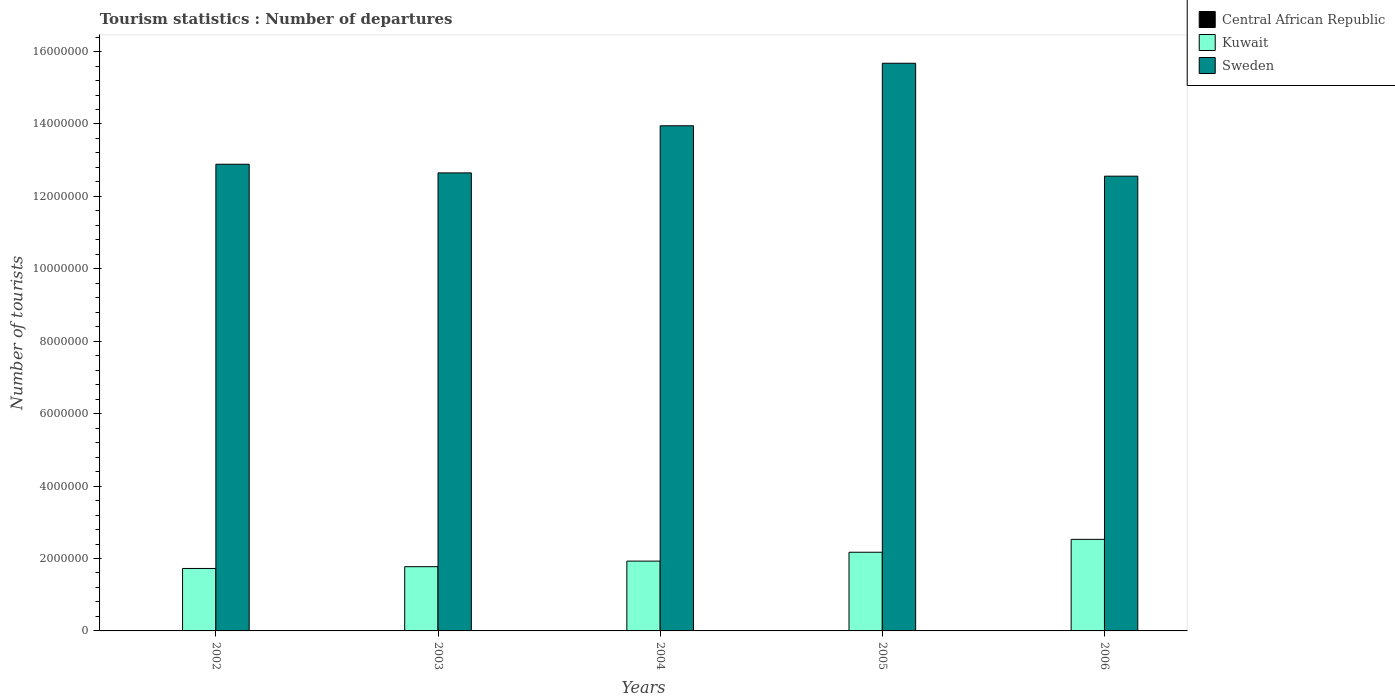Are the number of bars per tick equal to the number of legend labels?
Your answer should be very brief. Yes. Are the number of bars on each tick of the X-axis equal?
Your answer should be very brief. Yes. How many bars are there on the 4th tick from the right?
Keep it short and to the point. 3. What is the label of the 2nd group of bars from the left?
Keep it short and to the point. 2003. In how many cases, is the number of bars for a given year not equal to the number of legend labels?
Your answer should be very brief. 0. What is the number of tourist departures in Sweden in 2003?
Give a very brief answer. 1.26e+07. Across all years, what is the maximum number of tourist departures in Kuwait?
Provide a succinct answer. 2.53e+06. Across all years, what is the minimum number of tourist departures in Sweden?
Provide a succinct answer. 1.26e+07. In which year was the number of tourist departures in Central African Republic maximum?
Offer a terse response. 2006. In which year was the number of tourist departures in Kuwait minimum?
Provide a short and direct response. 2002. What is the total number of tourist departures in Sweden in the graph?
Your answer should be compact. 6.77e+07. What is the difference between the number of tourist departures in Sweden in 2002 and that in 2006?
Provide a short and direct response. 3.29e+05. What is the difference between the number of tourist departures in Kuwait in 2003 and the number of tourist departures in Sweden in 2002?
Make the answer very short. -1.11e+07. What is the average number of tourist departures in Central African Republic per year?
Provide a short and direct response. 7400. In the year 2003, what is the difference between the number of tourist departures in Central African Republic and number of tourist departures in Sweden?
Offer a very short reply. -1.26e+07. What is the ratio of the number of tourist departures in Kuwait in 2002 to that in 2005?
Your answer should be compact. 0.79. Is the difference between the number of tourist departures in Central African Republic in 2003 and 2006 greater than the difference between the number of tourist departures in Sweden in 2003 and 2006?
Offer a terse response. No. What is the difference between the highest and the second highest number of tourist departures in Kuwait?
Keep it short and to the point. 3.56e+05. What is the difference between the highest and the lowest number of tourist departures in Kuwait?
Give a very brief answer. 8.04e+05. In how many years, is the number of tourist departures in Central African Republic greater than the average number of tourist departures in Central African Republic taken over all years?
Your answer should be very brief. 2. What does the 1st bar from the left in 2006 represents?
Your answer should be compact. Central African Republic. What does the 2nd bar from the right in 2004 represents?
Offer a terse response. Kuwait. How many years are there in the graph?
Your answer should be compact. 5. What is the difference between two consecutive major ticks on the Y-axis?
Your answer should be very brief. 2.00e+06. Are the values on the major ticks of Y-axis written in scientific E-notation?
Offer a very short reply. No. Does the graph contain any zero values?
Give a very brief answer. No. How many legend labels are there?
Your answer should be compact. 3. How are the legend labels stacked?
Make the answer very short. Vertical. What is the title of the graph?
Your answer should be very brief. Tourism statistics : Number of departures. What is the label or title of the Y-axis?
Give a very brief answer. Number of tourists. What is the Number of tourists of Kuwait in 2002?
Ensure brevity in your answer.  1.72e+06. What is the Number of tourists of Sweden in 2002?
Provide a succinct answer. 1.29e+07. What is the Number of tourists of Central African Republic in 2003?
Offer a very short reply. 6000. What is the Number of tourists in Kuwait in 2003?
Your answer should be compact. 1.77e+06. What is the Number of tourists in Sweden in 2003?
Your response must be concise. 1.26e+07. What is the Number of tourists in Central African Republic in 2004?
Keep it short and to the point. 7000. What is the Number of tourists of Kuwait in 2004?
Ensure brevity in your answer.  1.93e+06. What is the Number of tourists of Sweden in 2004?
Ensure brevity in your answer.  1.40e+07. What is the Number of tourists of Central African Republic in 2005?
Give a very brief answer. 8000. What is the Number of tourists of Kuwait in 2005?
Give a very brief answer. 2.17e+06. What is the Number of tourists of Sweden in 2005?
Give a very brief answer. 1.57e+07. What is the Number of tourists in Central African Republic in 2006?
Provide a succinct answer. 1.10e+04. What is the Number of tourists in Kuwait in 2006?
Provide a succinct answer. 2.53e+06. What is the Number of tourists in Sweden in 2006?
Your answer should be compact. 1.26e+07. Across all years, what is the maximum Number of tourists of Central African Republic?
Give a very brief answer. 1.10e+04. Across all years, what is the maximum Number of tourists of Kuwait?
Ensure brevity in your answer.  2.53e+06. Across all years, what is the maximum Number of tourists of Sweden?
Offer a terse response. 1.57e+07. Across all years, what is the minimum Number of tourists in Kuwait?
Give a very brief answer. 1.72e+06. Across all years, what is the minimum Number of tourists of Sweden?
Give a very brief answer. 1.26e+07. What is the total Number of tourists in Central African Republic in the graph?
Offer a very short reply. 3.70e+04. What is the total Number of tourists in Kuwait in the graph?
Provide a succinct answer. 1.01e+07. What is the total Number of tourists in Sweden in the graph?
Your answer should be very brief. 6.77e+07. What is the difference between the Number of tourists in Central African Republic in 2002 and that in 2003?
Keep it short and to the point. -1000. What is the difference between the Number of tourists in Kuwait in 2002 and that in 2003?
Give a very brief answer. -4.90e+04. What is the difference between the Number of tourists in Sweden in 2002 and that in 2003?
Offer a terse response. 2.39e+05. What is the difference between the Number of tourists in Central African Republic in 2002 and that in 2004?
Offer a very short reply. -2000. What is the difference between the Number of tourists of Kuwait in 2002 and that in 2004?
Make the answer very short. -2.03e+05. What is the difference between the Number of tourists in Sweden in 2002 and that in 2004?
Ensure brevity in your answer.  -1.06e+06. What is the difference between the Number of tourists of Central African Republic in 2002 and that in 2005?
Offer a very short reply. -3000. What is the difference between the Number of tourists of Kuwait in 2002 and that in 2005?
Make the answer very short. -4.48e+05. What is the difference between the Number of tourists in Sweden in 2002 and that in 2005?
Provide a short and direct response. -2.79e+06. What is the difference between the Number of tourists of Central African Republic in 2002 and that in 2006?
Keep it short and to the point. -6000. What is the difference between the Number of tourists in Kuwait in 2002 and that in 2006?
Ensure brevity in your answer.  -8.04e+05. What is the difference between the Number of tourists of Sweden in 2002 and that in 2006?
Keep it short and to the point. 3.29e+05. What is the difference between the Number of tourists in Central African Republic in 2003 and that in 2004?
Keep it short and to the point. -1000. What is the difference between the Number of tourists in Kuwait in 2003 and that in 2004?
Ensure brevity in your answer.  -1.54e+05. What is the difference between the Number of tourists of Sweden in 2003 and that in 2004?
Offer a very short reply. -1.30e+06. What is the difference between the Number of tourists in Central African Republic in 2003 and that in 2005?
Offer a terse response. -2000. What is the difference between the Number of tourists of Kuwait in 2003 and that in 2005?
Make the answer very short. -3.99e+05. What is the difference between the Number of tourists of Sweden in 2003 and that in 2005?
Offer a terse response. -3.03e+06. What is the difference between the Number of tourists of Central African Republic in 2003 and that in 2006?
Give a very brief answer. -5000. What is the difference between the Number of tourists of Kuwait in 2003 and that in 2006?
Your answer should be very brief. -7.55e+05. What is the difference between the Number of tourists of Central African Republic in 2004 and that in 2005?
Offer a terse response. -1000. What is the difference between the Number of tourists in Kuwait in 2004 and that in 2005?
Your response must be concise. -2.45e+05. What is the difference between the Number of tourists in Sweden in 2004 and that in 2005?
Your response must be concise. -1.73e+06. What is the difference between the Number of tourists of Central African Republic in 2004 and that in 2006?
Give a very brief answer. -4000. What is the difference between the Number of tourists in Kuwait in 2004 and that in 2006?
Your response must be concise. -6.01e+05. What is the difference between the Number of tourists of Sweden in 2004 and that in 2006?
Your answer should be compact. 1.39e+06. What is the difference between the Number of tourists in Central African Republic in 2005 and that in 2006?
Your answer should be compact. -3000. What is the difference between the Number of tourists of Kuwait in 2005 and that in 2006?
Ensure brevity in your answer.  -3.56e+05. What is the difference between the Number of tourists in Sweden in 2005 and that in 2006?
Keep it short and to the point. 3.12e+06. What is the difference between the Number of tourists in Central African Republic in 2002 and the Number of tourists in Kuwait in 2003?
Provide a succinct answer. -1.77e+06. What is the difference between the Number of tourists of Central African Republic in 2002 and the Number of tourists of Sweden in 2003?
Provide a succinct answer. -1.26e+07. What is the difference between the Number of tourists of Kuwait in 2002 and the Number of tourists of Sweden in 2003?
Ensure brevity in your answer.  -1.09e+07. What is the difference between the Number of tourists of Central African Republic in 2002 and the Number of tourists of Kuwait in 2004?
Offer a terse response. -1.92e+06. What is the difference between the Number of tourists of Central African Republic in 2002 and the Number of tourists of Sweden in 2004?
Your answer should be compact. -1.39e+07. What is the difference between the Number of tourists in Kuwait in 2002 and the Number of tourists in Sweden in 2004?
Your answer should be compact. -1.22e+07. What is the difference between the Number of tourists of Central African Republic in 2002 and the Number of tourists of Kuwait in 2005?
Ensure brevity in your answer.  -2.17e+06. What is the difference between the Number of tourists of Central African Republic in 2002 and the Number of tourists of Sweden in 2005?
Keep it short and to the point. -1.57e+07. What is the difference between the Number of tourists in Kuwait in 2002 and the Number of tourists in Sweden in 2005?
Your answer should be very brief. -1.40e+07. What is the difference between the Number of tourists of Central African Republic in 2002 and the Number of tourists of Kuwait in 2006?
Provide a short and direct response. -2.52e+06. What is the difference between the Number of tourists in Central African Republic in 2002 and the Number of tourists in Sweden in 2006?
Ensure brevity in your answer.  -1.26e+07. What is the difference between the Number of tourists in Kuwait in 2002 and the Number of tourists in Sweden in 2006?
Provide a short and direct response. -1.08e+07. What is the difference between the Number of tourists of Central African Republic in 2003 and the Number of tourists of Kuwait in 2004?
Provide a succinct answer. -1.92e+06. What is the difference between the Number of tourists of Central African Republic in 2003 and the Number of tourists of Sweden in 2004?
Your answer should be compact. -1.39e+07. What is the difference between the Number of tourists in Kuwait in 2003 and the Number of tourists in Sweden in 2004?
Give a very brief answer. -1.22e+07. What is the difference between the Number of tourists in Central African Republic in 2003 and the Number of tourists in Kuwait in 2005?
Provide a short and direct response. -2.17e+06. What is the difference between the Number of tourists in Central African Republic in 2003 and the Number of tourists in Sweden in 2005?
Your answer should be very brief. -1.57e+07. What is the difference between the Number of tourists of Kuwait in 2003 and the Number of tourists of Sweden in 2005?
Offer a very short reply. -1.39e+07. What is the difference between the Number of tourists in Central African Republic in 2003 and the Number of tourists in Kuwait in 2006?
Offer a terse response. -2.52e+06. What is the difference between the Number of tourists in Central African Republic in 2003 and the Number of tourists in Sweden in 2006?
Your answer should be compact. -1.26e+07. What is the difference between the Number of tourists in Kuwait in 2003 and the Number of tourists in Sweden in 2006?
Provide a short and direct response. -1.08e+07. What is the difference between the Number of tourists of Central African Republic in 2004 and the Number of tourists of Kuwait in 2005?
Give a very brief answer. -2.17e+06. What is the difference between the Number of tourists of Central African Republic in 2004 and the Number of tourists of Sweden in 2005?
Offer a very short reply. -1.57e+07. What is the difference between the Number of tourists of Kuwait in 2004 and the Number of tourists of Sweden in 2005?
Provide a short and direct response. -1.37e+07. What is the difference between the Number of tourists of Central African Republic in 2004 and the Number of tourists of Kuwait in 2006?
Offer a terse response. -2.52e+06. What is the difference between the Number of tourists of Central African Republic in 2004 and the Number of tourists of Sweden in 2006?
Give a very brief answer. -1.26e+07. What is the difference between the Number of tourists of Kuwait in 2004 and the Number of tourists of Sweden in 2006?
Give a very brief answer. -1.06e+07. What is the difference between the Number of tourists of Central African Republic in 2005 and the Number of tourists of Kuwait in 2006?
Offer a very short reply. -2.52e+06. What is the difference between the Number of tourists of Central African Republic in 2005 and the Number of tourists of Sweden in 2006?
Keep it short and to the point. -1.26e+07. What is the difference between the Number of tourists in Kuwait in 2005 and the Number of tourists in Sweden in 2006?
Offer a very short reply. -1.04e+07. What is the average Number of tourists of Central African Republic per year?
Make the answer very short. 7400. What is the average Number of tourists of Kuwait per year?
Keep it short and to the point. 2.03e+06. What is the average Number of tourists in Sweden per year?
Provide a succinct answer. 1.35e+07. In the year 2002, what is the difference between the Number of tourists in Central African Republic and Number of tourists in Kuwait?
Your answer should be very brief. -1.72e+06. In the year 2002, what is the difference between the Number of tourists in Central African Republic and Number of tourists in Sweden?
Your answer should be compact. -1.29e+07. In the year 2002, what is the difference between the Number of tourists in Kuwait and Number of tourists in Sweden?
Keep it short and to the point. -1.12e+07. In the year 2003, what is the difference between the Number of tourists in Central African Republic and Number of tourists in Kuwait?
Offer a very short reply. -1.77e+06. In the year 2003, what is the difference between the Number of tourists in Central African Republic and Number of tourists in Sweden?
Provide a succinct answer. -1.26e+07. In the year 2003, what is the difference between the Number of tourists in Kuwait and Number of tourists in Sweden?
Provide a short and direct response. -1.09e+07. In the year 2004, what is the difference between the Number of tourists in Central African Republic and Number of tourists in Kuwait?
Give a very brief answer. -1.92e+06. In the year 2004, what is the difference between the Number of tourists in Central African Republic and Number of tourists in Sweden?
Offer a terse response. -1.39e+07. In the year 2004, what is the difference between the Number of tourists of Kuwait and Number of tourists of Sweden?
Give a very brief answer. -1.20e+07. In the year 2005, what is the difference between the Number of tourists of Central African Republic and Number of tourists of Kuwait?
Offer a very short reply. -2.16e+06. In the year 2005, what is the difference between the Number of tourists in Central African Republic and Number of tourists in Sweden?
Your answer should be very brief. -1.57e+07. In the year 2005, what is the difference between the Number of tourists of Kuwait and Number of tourists of Sweden?
Keep it short and to the point. -1.35e+07. In the year 2006, what is the difference between the Number of tourists in Central African Republic and Number of tourists in Kuwait?
Your answer should be very brief. -2.52e+06. In the year 2006, what is the difference between the Number of tourists of Central African Republic and Number of tourists of Sweden?
Make the answer very short. -1.25e+07. In the year 2006, what is the difference between the Number of tourists of Kuwait and Number of tourists of Sweden?
Make the answer very short. -1.00e+07. What is the ratio of the Number of tourists of Kuwait in 2002 to that in 2003?
Offer a terse response. 0.97. What is the ratio of the Number of tourists in Sweden in 2002 to that in 2003?
Keep it short and to the point. 1.02. What is the ratio of the Number of tourists of Central African Republic in 2002 to that in 2004?
Your answer should be compact. 0.71. What is the ratio of the Number of tourists in Kuwait in 2002 to that in 2004?
Make the answer very short. 0.89. What is the ratio of the Number of tourists in Sweden in 2002 to that in 2004?
Ensure brevity in your answer.  0.92. What is the ratio of the Number of tourists of Central African Republic in 2002 to that in 2005?
Your response must be concise. 0.62. What is the ratio of the Number of tourists in Kuwait in 2002 to that in 2005?
Give a very brief answer. 0.79. What is the ratio of the Number of tourists of Sweden in 2002 to that in 2005?
Offer a very short reply. 0.82. What is the ratio of the Number of tourists in Central African Republic in 2002 to that in 2006?
Your response must be concise. 0.45. What is the ratio of the Number of tourists of Kuwait in 2002 to that in 2006?
Your answer should be very brief. 0.68. What is the ratio of the Number of tourists in Sweden in 2002 to that in 2006?
Your response must be concise. 1.03. What is the ratio of the Number of tourists of Kuwait in 2003 to that in 2004?
Provide a short and direct response. 0.92. What is the ratio of the Number of tourists in Sweden in 2003 to that in 2004?
Provide a short and direct response. 0.91. What is the ratio of the Number of tourists of Central African Republic in 2003 to that in 2005?
Provide a short and direct response. 0.75. What is the ratio of the Number of tourists in Kuwait in 2003 to that in 2005?
Your answer should be very brief. 0.82. What is the ratio of the Number of tourists of Sweden in 2003 to that in 2005?
Your answer should be very brief. 0.81. What is the ratio of the Number of tourists of Central African Republic in 2003 to that in 2006?
Provide a short and direct response. 0.55. What is the ratio of the Number of tourists of Kuwait in 2003 to that in 2006?
Your response must be concise. 0.7. What is the ratio of the Number of tourists of Sweden in 2003 to that in 2006?
Make the answer very short. 1.01. What is the ratio of the Number of tourists of Kuwait in 2004 to that in 2005?
Provide a short and direct response. 0.89. What is the ratio of the Number of tourists in Sweden in 2004 to that in 2005?
Make the answer very short. 0.89. What is the ratio of the Number of tourists of Central African Republic in 2004 to that in 2006?
Your response must be concise. 0.64. What is the ratio of the Number of tourists in Kuwait in 2004 to that in 2006?
Provide a succinct answer. 0.76. What is the ratio of the Number of tourists in Sweden in 2004 to that in 2006?
Offer a very short reply. 1.11. What is the ratio of the Number of tourists of Central African Republic in 2005 to that in 2006?
Your answer should be compact. 0.73. What is the ratio of the Number of tourists of Kuwait in 2005 to that in 2006?
Your answer should be very brief. 0.86. What is the ratio of the Number of tourists of Sweden in 2005 to that in 2006?
Your response must be concise. 1.25. What is the difference between the highest and the second highest Number of tourists in Central African Republic?
Offer a terse response. 3000. What is the difference between the highest and the second highest Number of tourists of Kuwait?
Provide a succinct answer. 3.56e+05. What is the difference between the highest and the second highest Number of tourists in Sweden?
Give a very brief answer. 1.73e+06. What is the difference between the highest and the lowest Number of tourists of Central African Republic?
Offer a very short reply. 6000. What is the difference between the highest and the lowest Number of tourists in Kuwait?
Make the answer very short. 8.04e+05. What is the difference between the highest and the lowest Number of tourists in Sweden?
Give a very brief answer. 3.12e+06. 